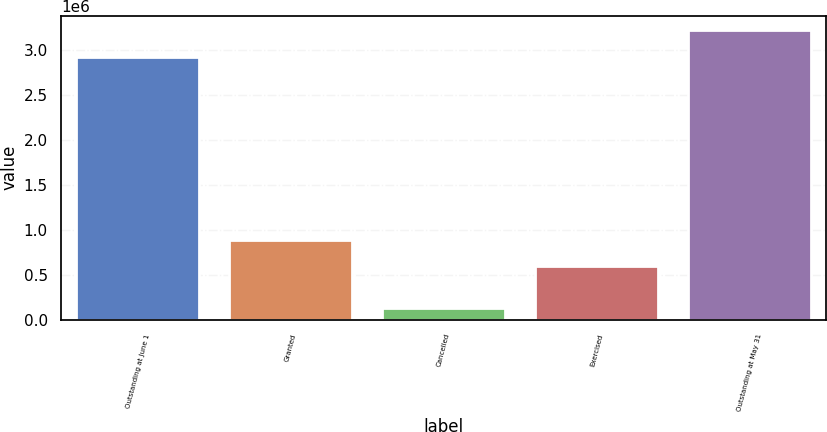Convert chart to OTSL. <chart><loc_0><loc_0><loc_500><loc_500><bar_chart><fcel>Outstanding at June 1<fcel>Granted<fcel>Cancelled<fcel>Exercised<fcel>Outstanding at May 31<nl><fcel>2.92708e+06<fcel>892410<fcel>135709<fcel>596859<fcel>3.2222e+06<nl></chart> 